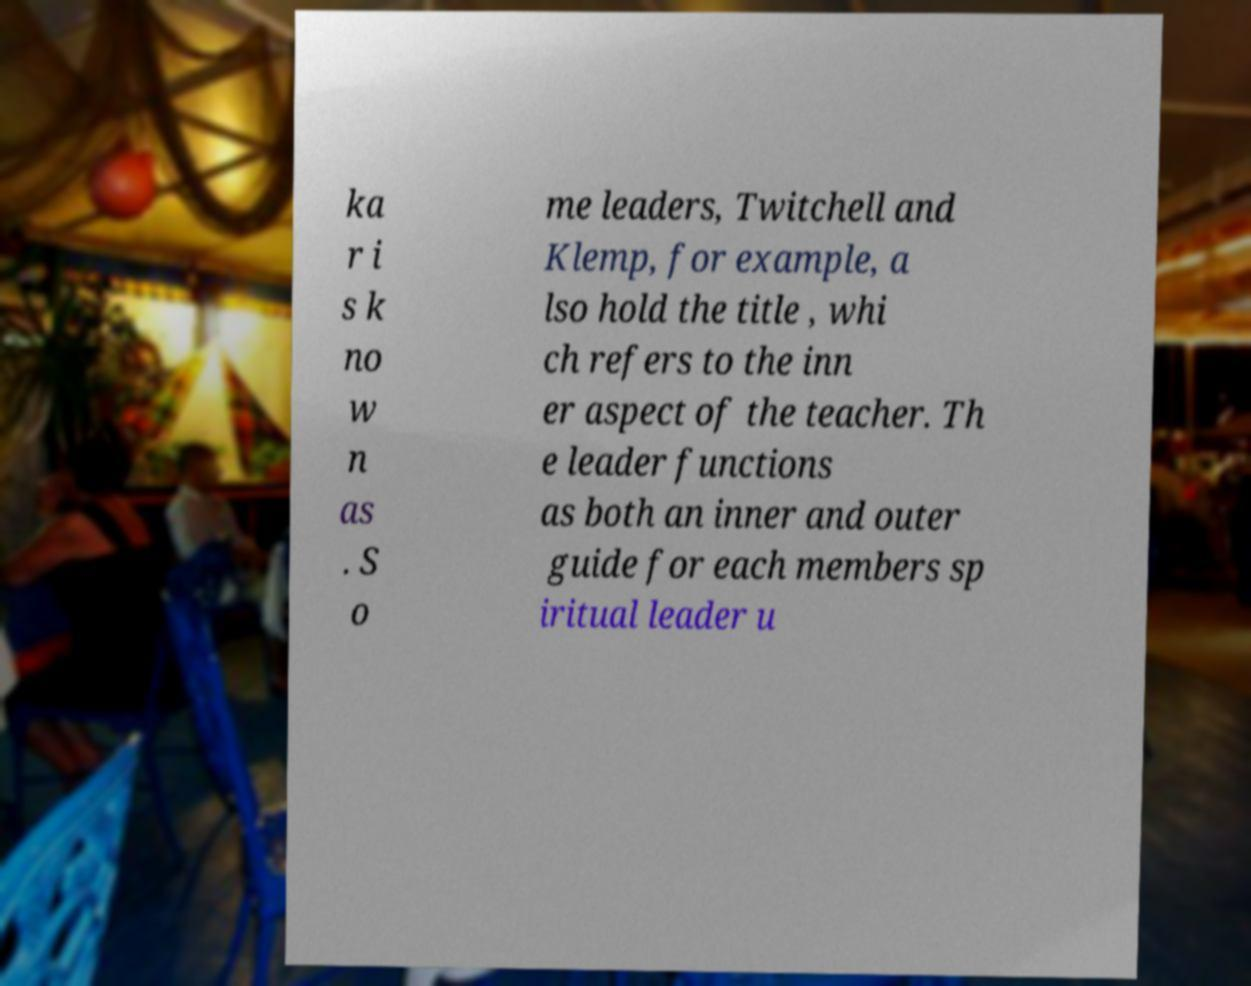Can you read and provide the text displayed in the image?This photo seems to have some interesting text. Can you extract and type it out for me? ka r i s k no w n as . S o me leaders, Twitchell and Klemp, for example, a lso hold the title , whi ch refers to the inn er aspect of the teacher. Th e leader functions as both an inner and outer guide for each members sp iritual leader u 